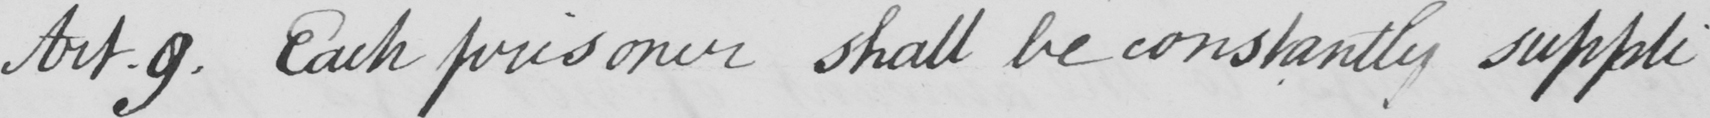Transcribe the text shown in this historical manuscript line. Art.9. Each prisoner shall be constantly suppli- 